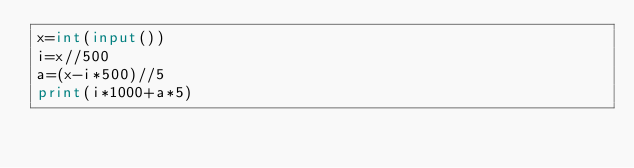Convert code to text. <code><loc_0><loc_0><loc_500><loc_500><_Python_>x=int(input())
i=x//500
a=(x-i*500)//5
print(i*1000+a*5)
</code> 